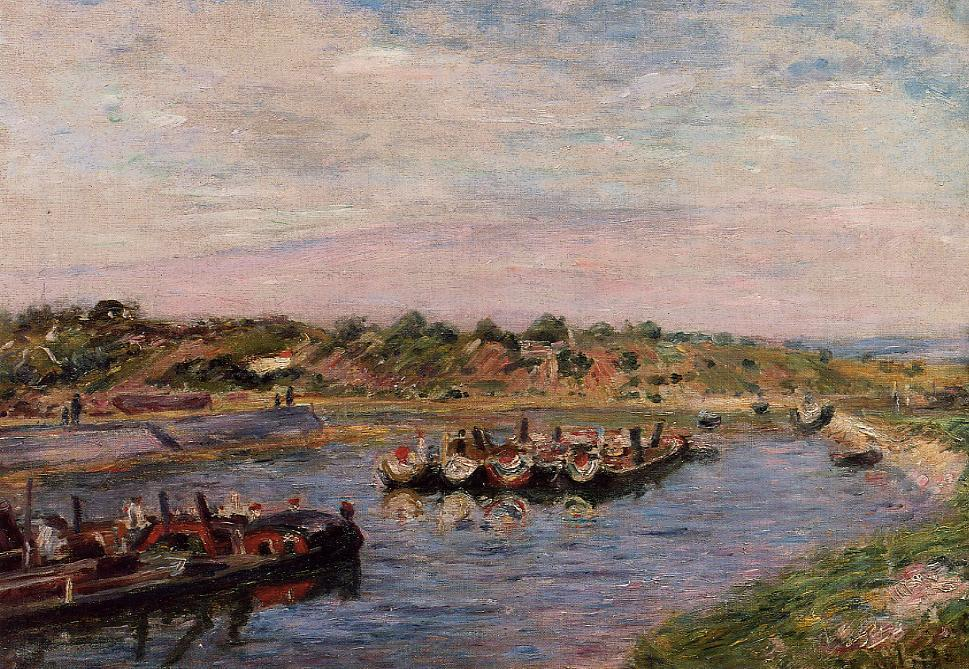How does the artist use color to affect the mood of the painting? The artist skillfully employs a palette of pastels to create a mood that is both lively and tranquil. The predominance of blues and greens around the river fosters a soothing ambiance, while splashes of pinks and light reds add vibrancy and dynamism, suggesting the lively activity of the scene. This strategic use of color not only depicts the physical environment but also evokes an emotional response, inviting viewers to feel the joy and serenity of the scene. 